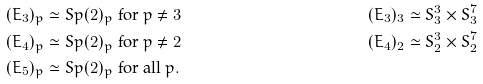<formula> <loc_0><loc_0><loc_500><loc_500>( E _ { 3 } ) _ { p } & \simeq S p ( 2 ) _ { p } \text { for } p \not = 3 & ( E _ { 3 } ) _ { 3 } & \simeq S ^ { 3 } _ { 3 } \times S ^ { 7 } _ { 3 } \\ ( E _ { 4 } ) _ { p } & \simeq S p ( 2 ) _ { p } \text { for } p \not = 2 & ( E _ { 4 } ) _ { 2 } & \simeq S ^ { 3 } _ { 2 } \times S ^ { 7 } _ { 2 } \\ ( E _ { 5 } ) _ { p } & \simeq S p ( 2 ) _ { p } \text { for all } p .</formula> 